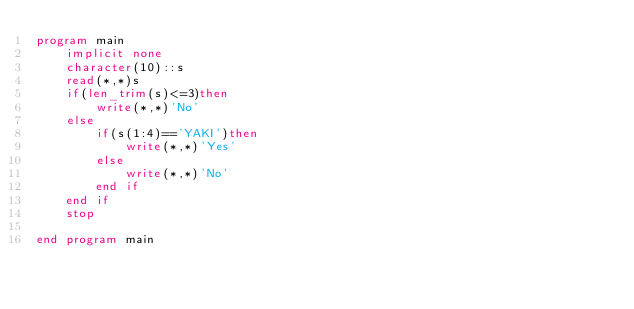Convert code to text. <code><loc_0><loc_0><loc_500><loc_500><_FORTRAN_>program main
	implicit none
    character(10)::s
    read(*,*)s
    if(len_trim(s)<=3)then
    	write(*,*)'No'
    else
    	if(s(1:4)=='YAKI')then
        	write(*,*)'Yes'
        else
        	write(*,*)'No'
        end if
    end if
    stop
    
end program main</code> 